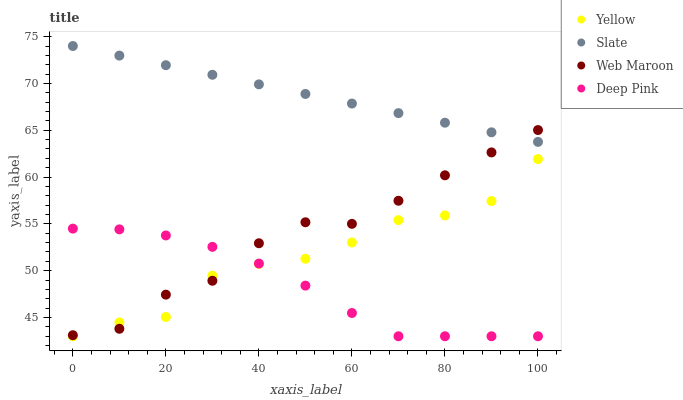Does Deep Pink have the minimum area under the curve?
Answer yes or no. Yes. Does Slate have the maximum area under the curve?
Answer yes or no. Yes. Does Web Maroon have the minimum area under the curve?
Answer yes or no. No. Does Web Maroon have the maximum area under the curve?
Answer yes or no. No. Is Slate the smoothest?
Answer yes or no. Yes. Is Yellow the roughest?
Answer yes or no. Yes. Is Deep Pink the smoothest?
Answer yes or no. No. Is Deep Pink the roughest?
Answer yes or no. No. Does Deep Pink have the lowest value?
Answer yes or no. Yes. Does Web Maroon have the lowest value?
Answer yes or no. No. Does Slate have the highest value?
Answer yes or no. Yes. Does Web Maroon have the highest value?
Answer yes or no. No. Is Deep Pink less than Slate?
Answer yes or no. Yes. Is Slate greater than Yellow?
Answer yes or no. Yes. Does Slate intersect Web Maroon?
Answer yes or no. Yes. Is Slate less than Web Maroon?
Answer yes or no. No. Is Slate greater than Web Maroon?
Answer yes or no. No. Does Deep Pink intersect Slate?
Answer yes or no. No. 